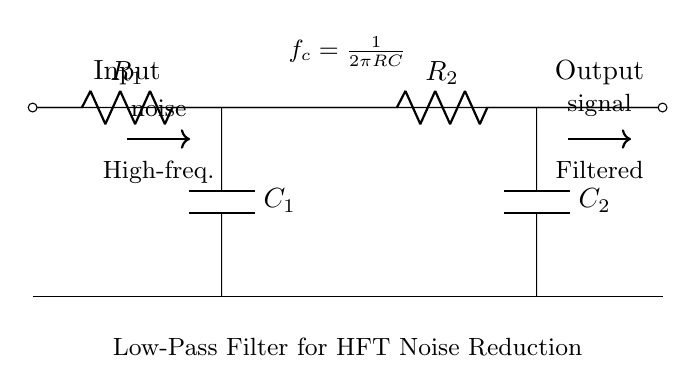What is the input of the circuit? The input is located at the left side of the circuit diagram, denoted by the label "Input". It is connected to the resistor R1.
Answer: Input What type of components are used in this circuit? The circuit includes resistors labeled R1 and R2, and capacitors labeled C1 and C2. These are the basic circuit elements depicted.
Answer: Resistors and capacitors What is the total number of resistors in the circuit? There are two resistors, R1 and R2, shown in the circuit. Each is connected in series with the capacitors.
Answer: 2 What is the function of the capacitors in this circuit? The capacitors are used to block high-frequency signals while allowing low-frequency signals to pass through, thus filtering noise. This is the primary function of capacitors in a low-pass filter circuit.
Answer: Noise reduction How is the cutoff frequency calculated? The cutoff frequency is determined using the formula f_c equals one divided by two pi times the product of resistance and capacitance (R and C). The circuit shows this equation, demonstrating how it controls the frequency response.
Answer: f_c = 1/(2πRC) What is the output of the circuit? The output is located at the right side of the circuit diagram, labeled "Output", where the filtered signal is taken after passing through the components.
Answer: Output Why are two resistors used in this circuit? The use of two resistors allows for better tuning of the cutoff frequency and the overall filter response. Each resistor serves to shape the frequency response of the filter and ensure effective noise reduction across the desired operational bandwidth.
Answer: Better frequency tuning 